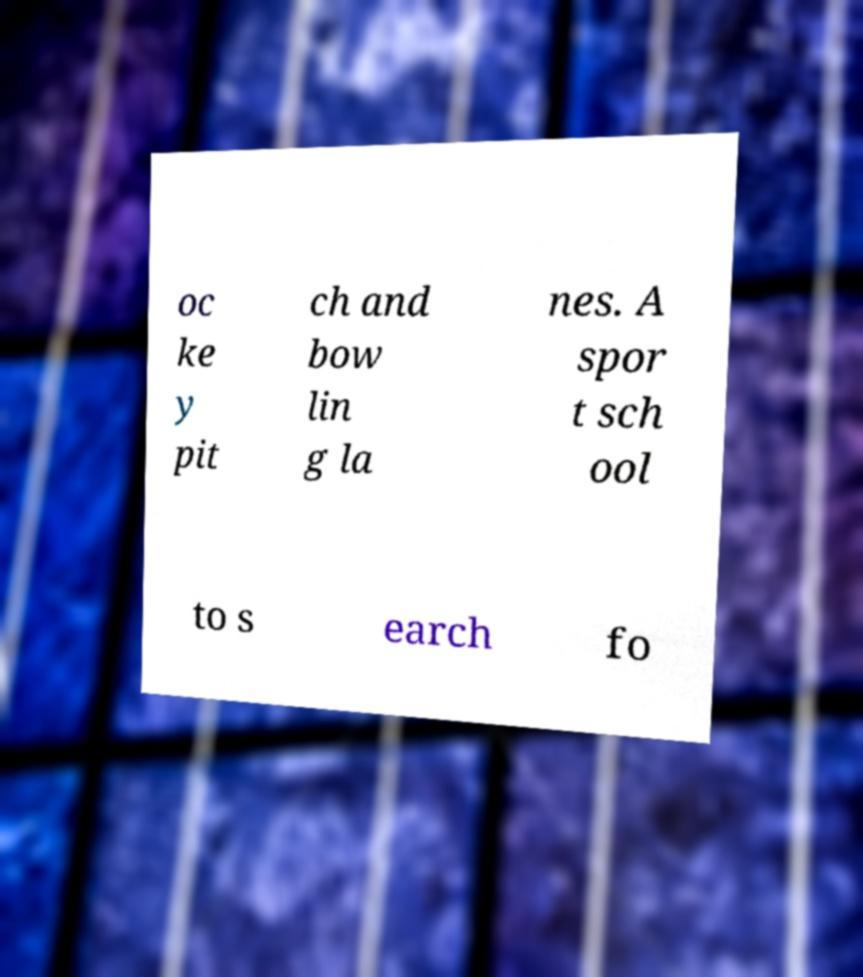Could you extract and type out the text from this image? oc ke y pit ch and bow lin g la nes. A spor t sch ool to s earch fo 